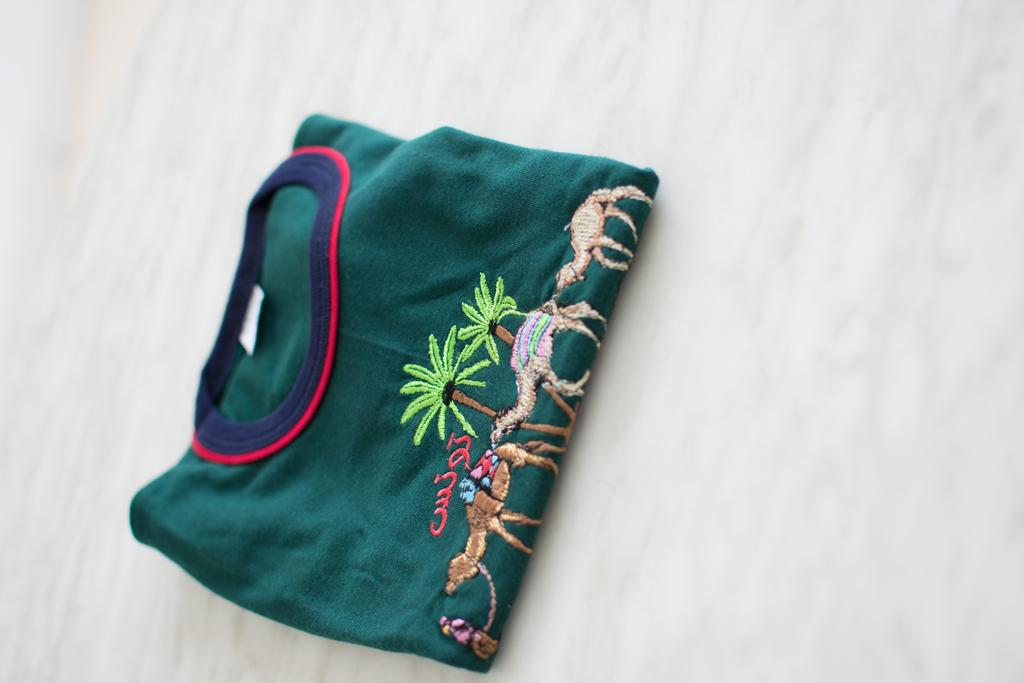What type of clothing item is in the picture? There is a t-shirt in the picture. What design or detail can be seen on the t-shirt? The t-shirt has embroidery work on it. What type of thrill can be seen on the stage in the image? There is no stage or thrill present in the image; it only features a t-shirt with embroidery work. 